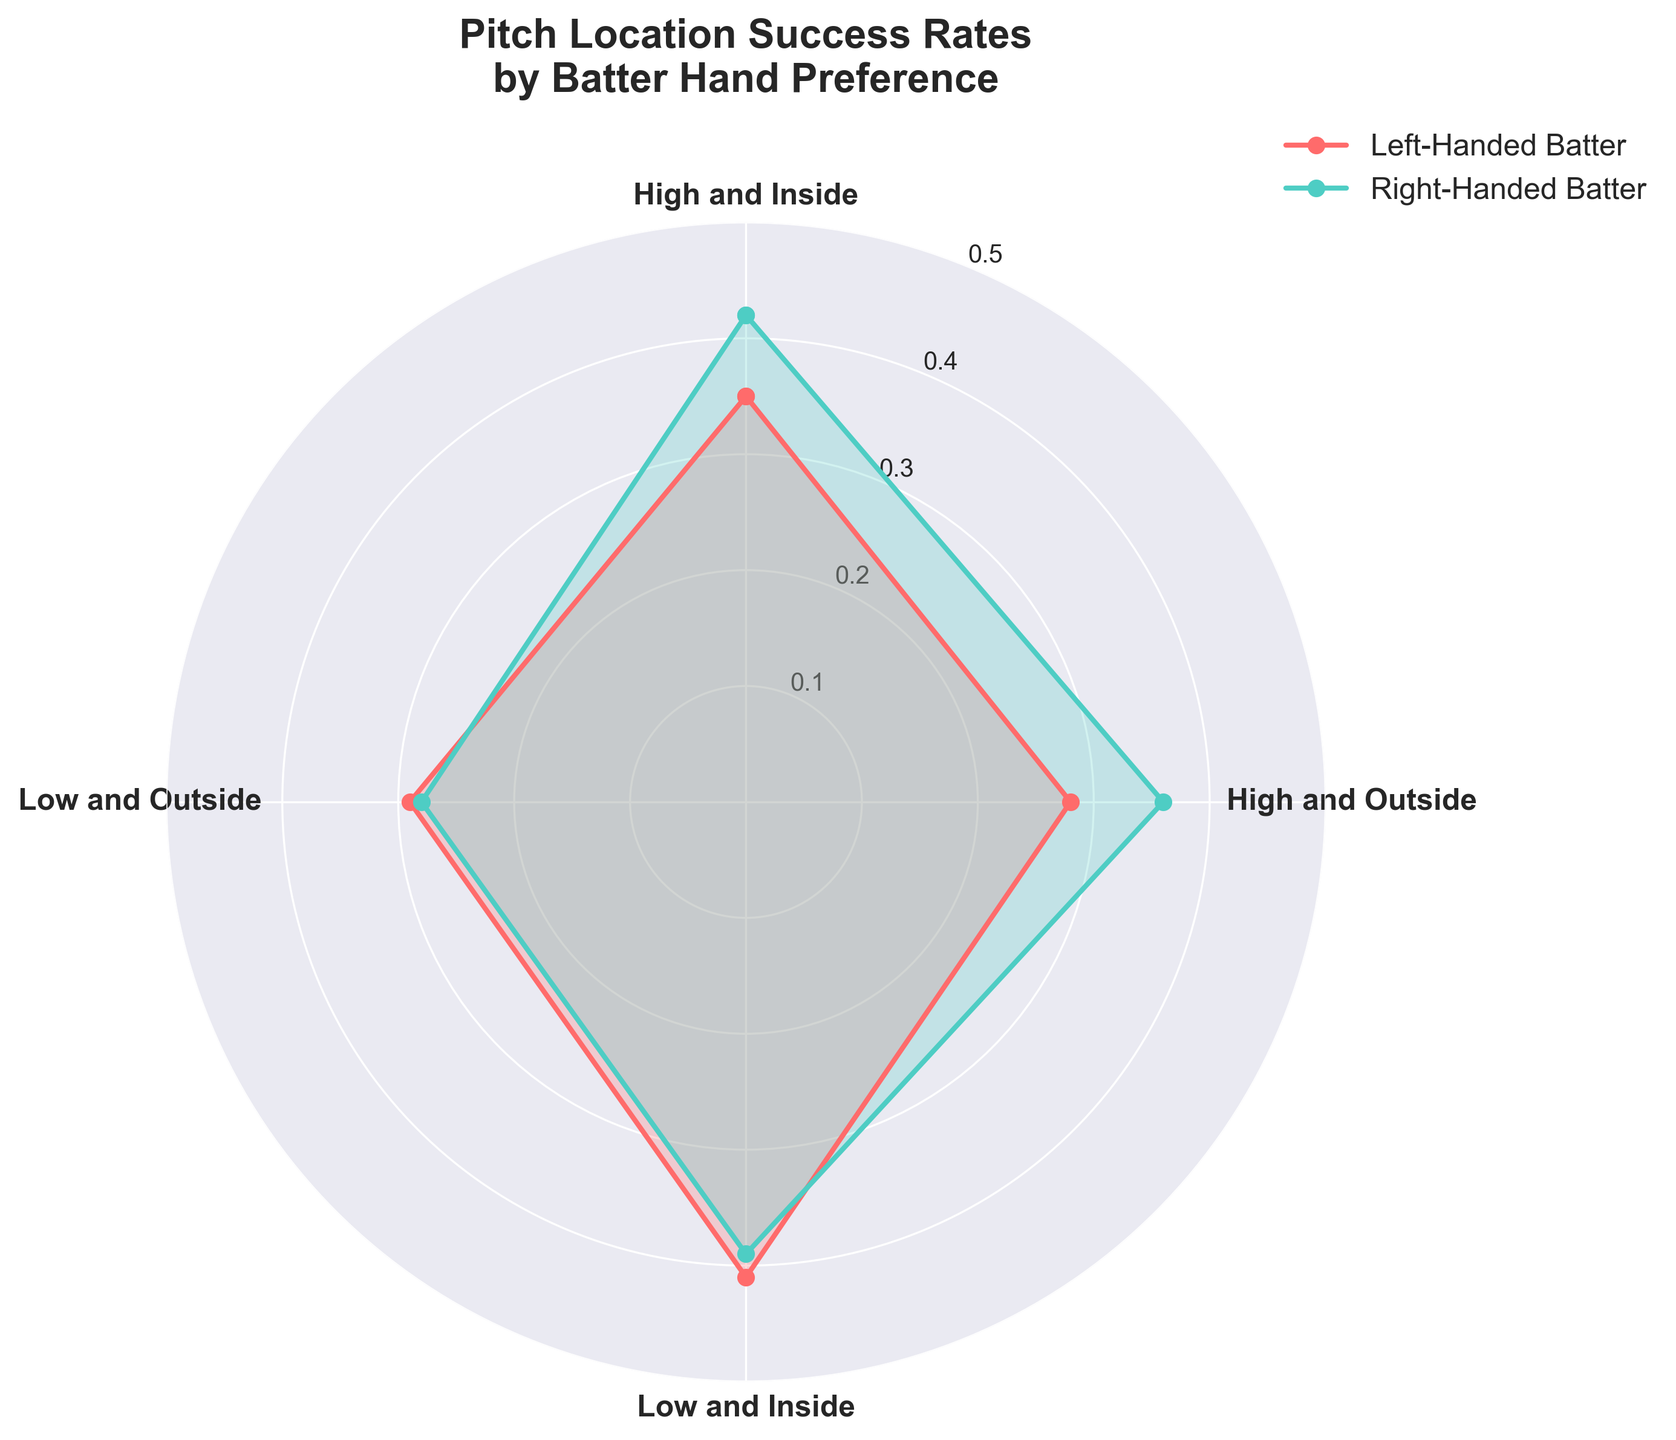what is the title of the figure? The title is usually located at the top center of the figure. In this case, it reads "Pitch Location Success Rates by Batter Hand Preference".
Answer: Pitch Location Success Rates by Batter Hand Preference Which location has the highest success rate for left-handed batters? By looking at the rose chart, the highest point for the left-handed batters (marked in red) is at "Low and Inside".
Answer: Low and Inside What is the success rate for right-handed batters at "High and Outside" pitch location? The success rate can be identified by observing the data point on the chart for right-handed batters (marked in green) at the "High and Outside" location.
Answer: 0.360 Compare the success rates between left-handed and right-handed batters for "Low and Outside" pitch location. Check the data points for "Low and Outside". The left-handed batter success rate is 0.290 and the right-handed batter success rate is 0.280. Comparing these values show that left-handed batters have a slightly higher success rate.
Answer: Left-handed batters Which pitch location shows the smallest difference in success rates between left-handed and right-handed batters? To find the smallest difference, subtract the success rate of right-handed batters from left-handed batters for each pitch location. The smallest difference is at "Low and Outside" where the difference is 0.010 (0.290 - 0.280).
Answer: Low and Outside What is the average success rate for left-handed batters across all pitch locations? Add the success rates for left-handed batters (0.350, 0.280, 0.410, 0.290) and divide by 4. The sum is 1.330, so the average is 1.330 / 4 = 0.3325.
Answer: 0.3325 Which batter hand preference has a higher success rate for "High and Inside" pitches and by how much? Compare the success rates at "High and Inside" location: left-handed batter is 0.350 and right-handed batter is 0.420. The right-handed batter has a higher success rate by the difference of 0.420 - 0.350 = 0.070.
Answer: Right-handed batter, 0.070 How many pitch locations are analyzed in this figure? By counting the pitch locations listed in the chart, we see there are four: "High and Inside", "High and Outside", "Low and Inside", and "Low and Outside".
Answer: Four 